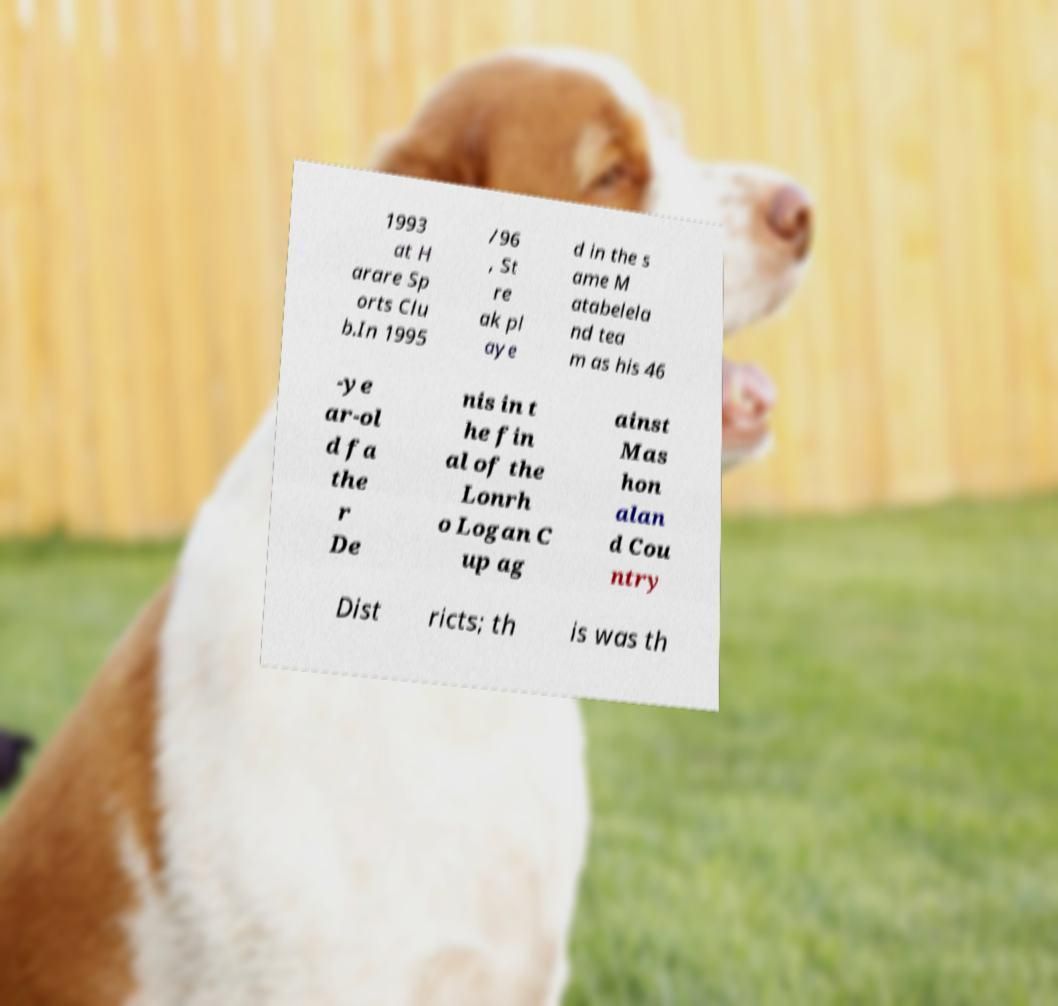I need the written content from this picture converted into text. Can you do that? 1993 at H arare Sp orts Clu b.In 1995 /96 , St re ak pl aye d in the s ame M atabelela nd tea m as his 46 -ye ar-ol d fa the r De nis in t he fin al of the Lonrh o Logan C up ag ainst Mas hon alan d Cou ntry Dist ricts; th is was th 